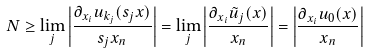<formula> <loc_0><loc_0><loc_500><loc_500>N \geq \lim _ { j } \left | \frac { \partial _ { x _ { i } } u _ { k _ { j } } ( s _ { j } x ) } { s _ { j } x _ { n } } \right | = \lim _ { j } \left | \frac { \partial _ { x _ { i } } \tilde { u } _ { j } ( x ) } { x _ { n } } \right | = \left | \frac { \partial _ { x _ { i } } u _ { 0 } ( x ) } { x _ { n } } \right |</formula> 